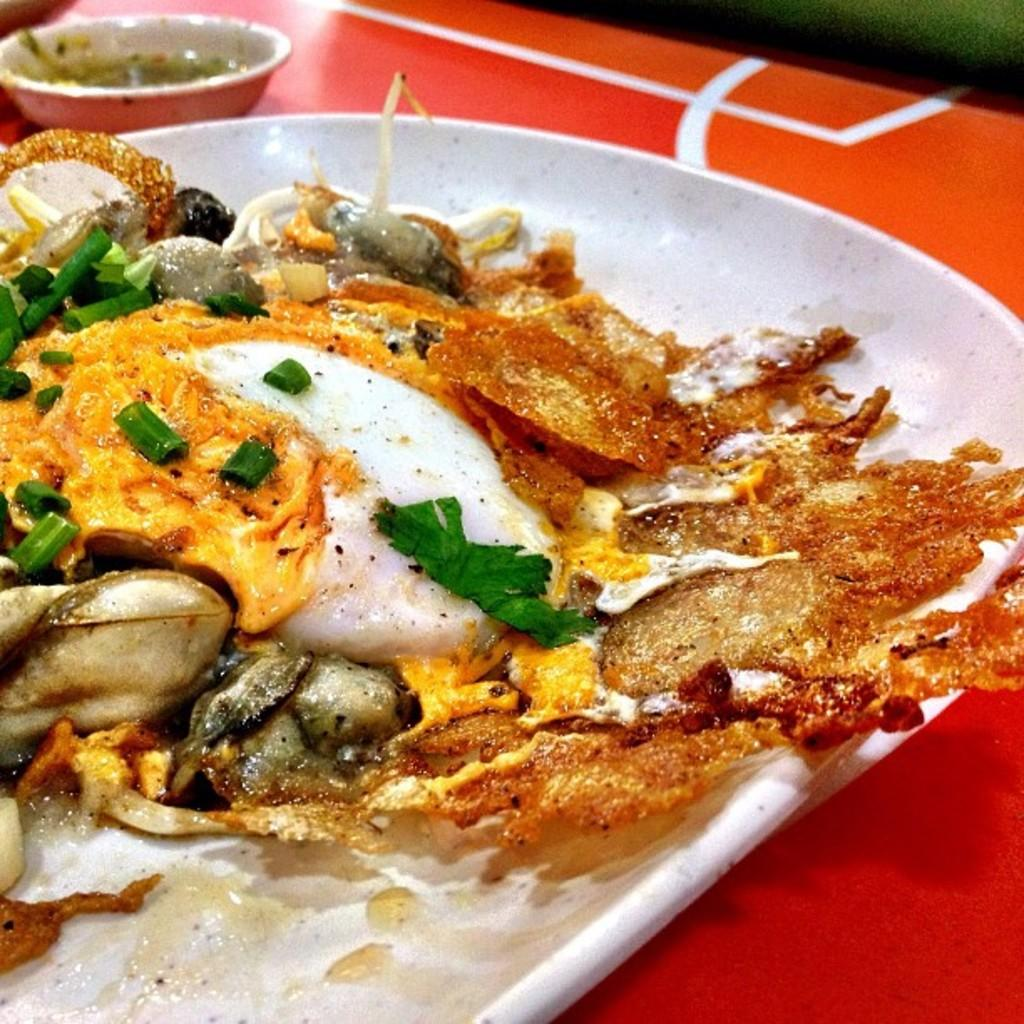What is the main food item visible in the image? There is a food item in a plate in the image. Where is the plate with the food item located? The plate is on a table. What else can be seen on the table besides the plate? There is a bowl in the image. What is the purpose of the bowl? The bowl contains sauce. How many mailboxes are visible in the image? There are no mailboxes present in the image. What is the color of the sky in the image? The provided facts do not mention the sky or its color, so we cannot determine that information from the image. 